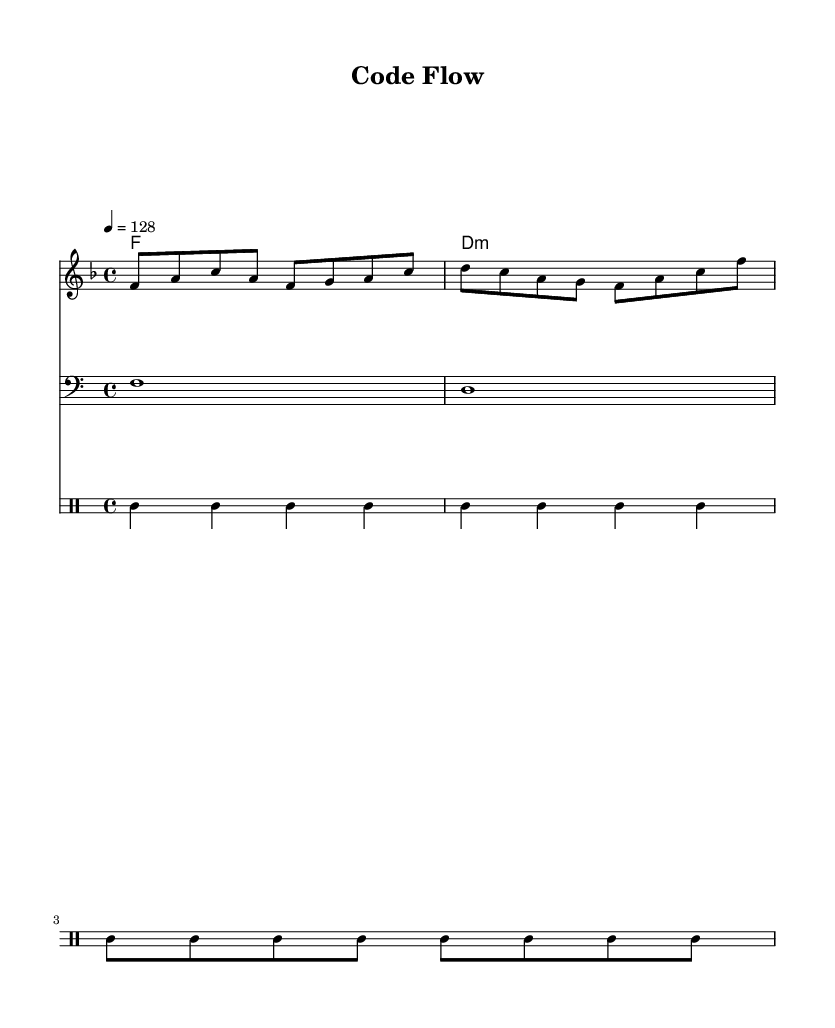What is the key signature of this music? The key signature is F major, which has one flat (B♭). This can be determined by looking at the key signature indicated at the beginning of the score.
Answer: F major What is the time signature of this music? The time signature is 4/4. This is indicated at the beginning of the score and specifies that there are four beats in a measure and a quarter note receives one beat.
Answer: 4/4 What is the tempo marking of this music? The tempo marking is 128 beats per minute. This is shown in the score with the notation '4 = 128', indicating the speed at which the piece should be played.
Answer: 128 How many measures are in the melody section? The melody section contains four measures. This can be confirmed by counting the groups that are divided by vertical lines in the melody staff.
Answer: 4 What type of chord is used in the harmony section? The harmony section features a D minor chord. The chord is indicated in chord notation, and the lowercase 'm' denotes that it is a minor chord.
Answer: D minor What instruments are represented in this score? The score includes a melody instrument, a bass instrument, and a drum set. This can be identified by the different staves labeled for each specific part in the score layout.
Answer: Melody, Bass, Drums Is the drum pattern steady or variable throughout the measures? The drum pattern is steady, with consistent bass drum hits in each measure. Observing the rhythmic patterns in the drum staff indicates that the bass drum plays on every beat.
Answer: Steady 